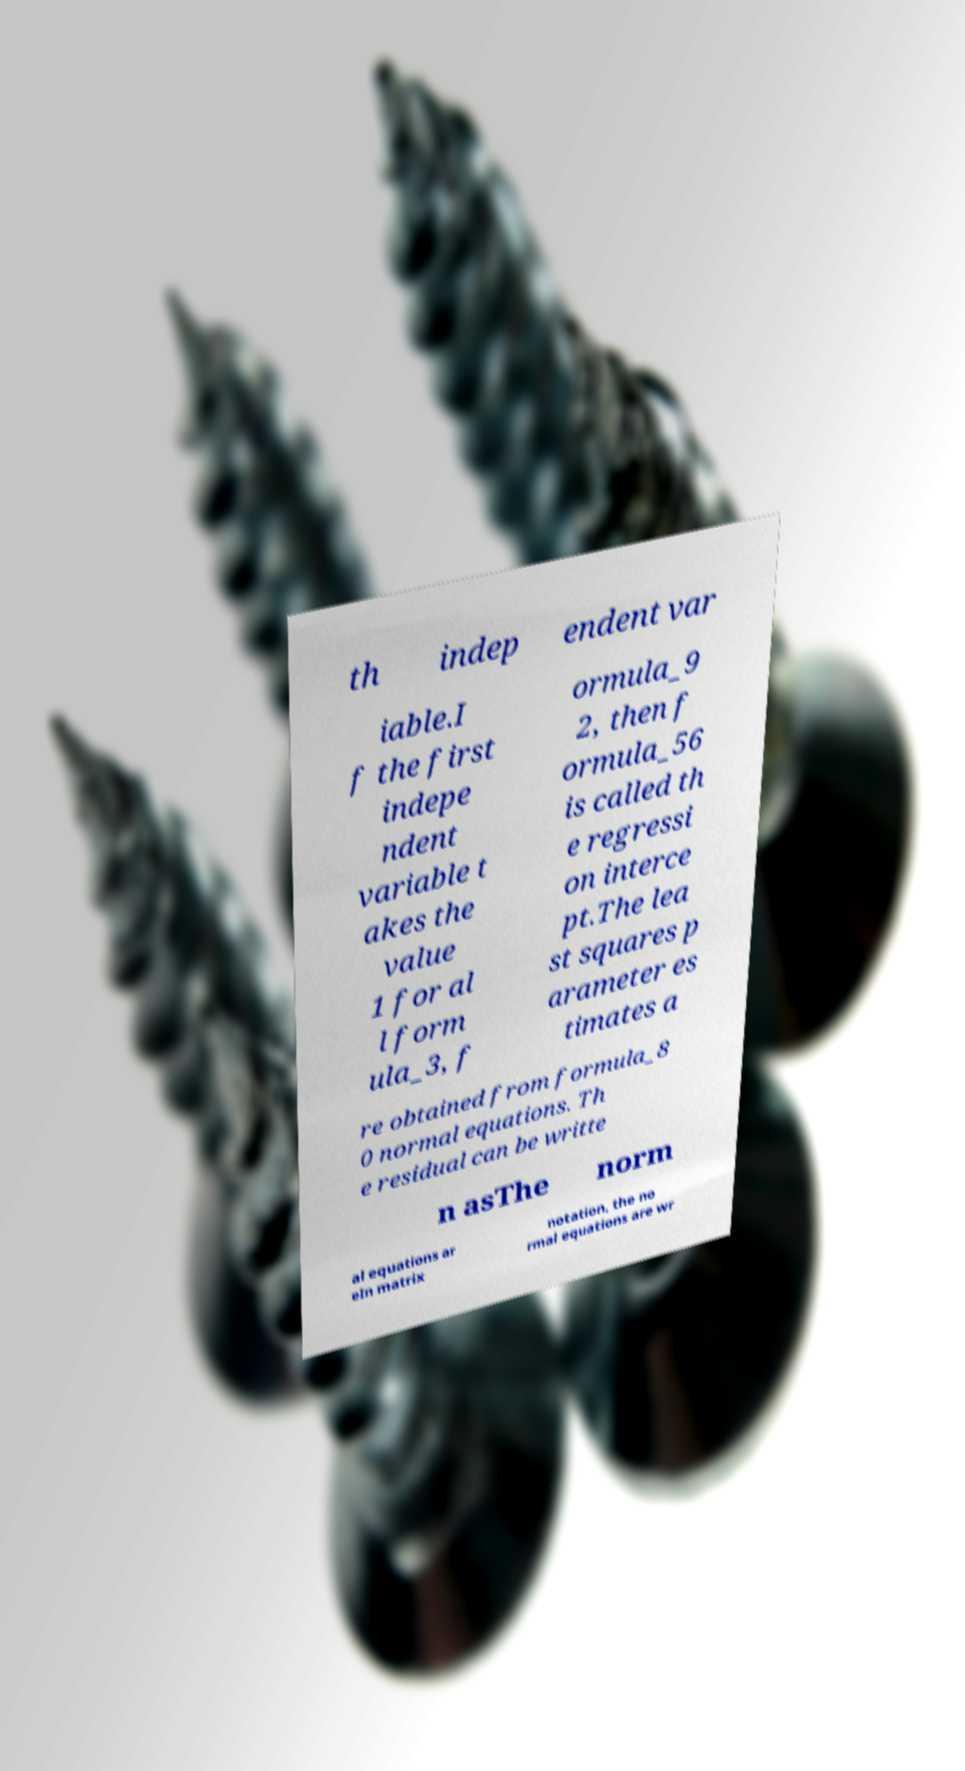Could you extract and type out the text from this image? th indep endent var iable.I f the first indepe ndent variable t akes the value 1 for al l form ula_3, f ormula_9 2, then f ormula_56 is called th e regressi on interce pt.The lea st squares p arameter es timates a re obtained from formula_8 0 normal equations. Th e residual can be writte n asThe norm al equations ar eIn matrix notation, the no rmal equations are wr 